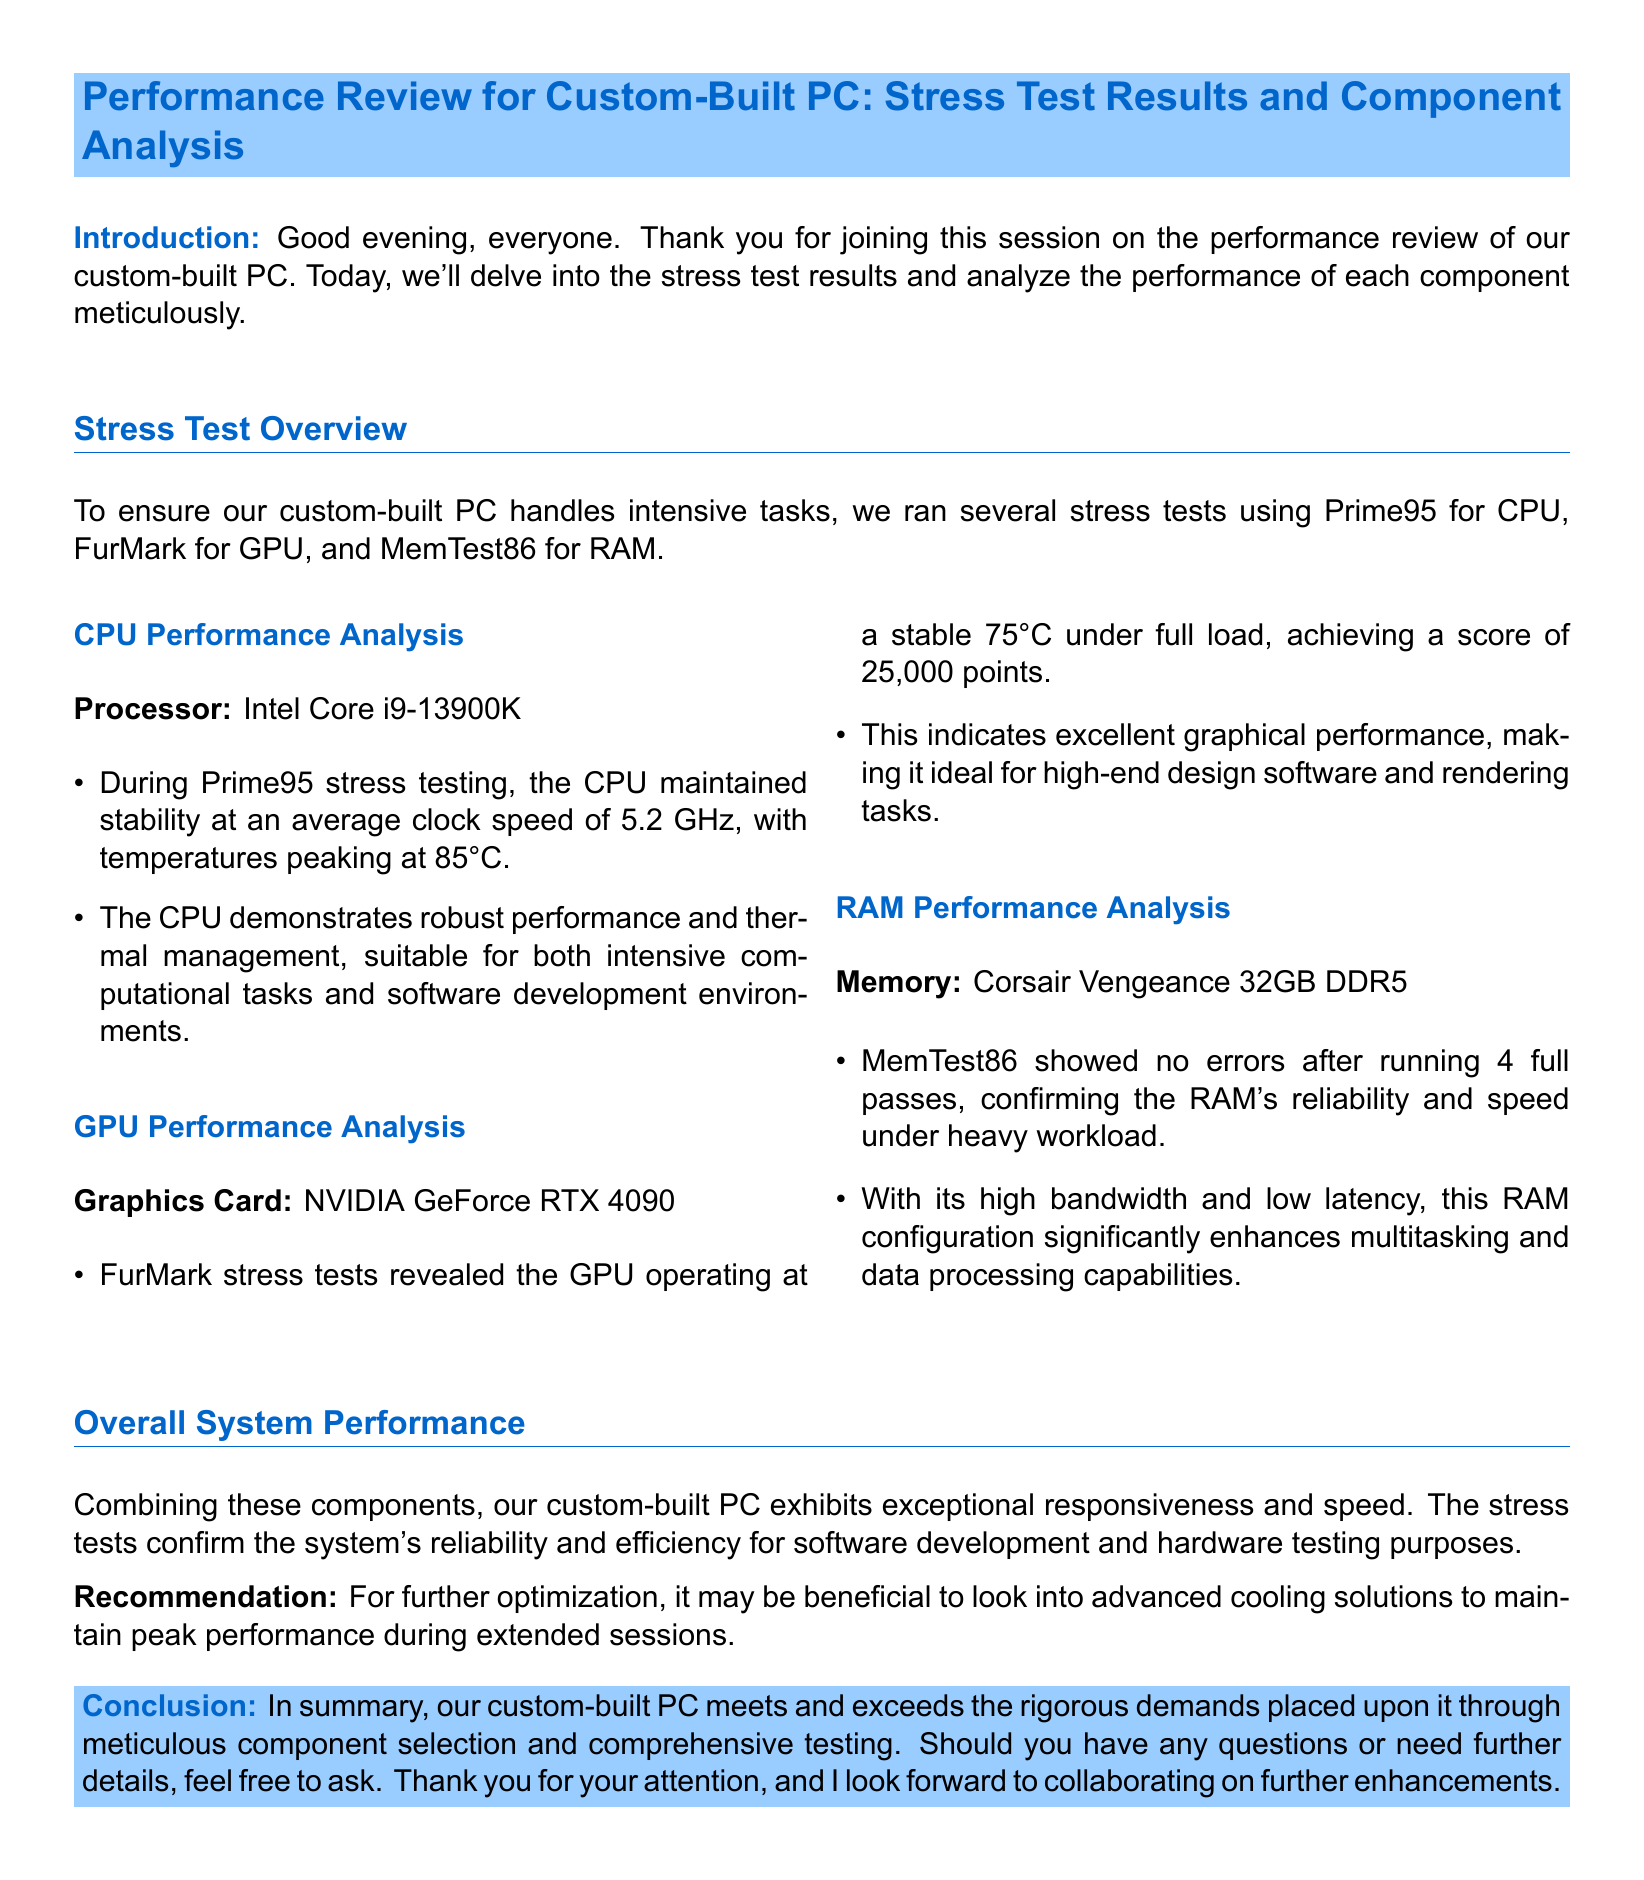What stress testing software was used for the CPU? The document specifies that Prime95 was the software used for CPU stress testing.
Answer: Prime95 What was the peak temperature for the CPU during testing? According to the document, the CPU peaked at a temperature of 85°C during stress testing.
Answer: 85°C What is the average clock speed of the Intel Core i9-13900K CPU? The document states that the CPU maintained an average clock speed of 5.2 GHz during testing.
Answer: 5.2 GHz How many full passes did MemTest86 run? The document mentions that MemTest86 showed no errors after running 4 full passes.
Answer: 4 What was the score achieved by the NVIDIA GeForce RTX 4090 during the stress test? The document indicates that the GPU achieved a score of 25,000 points in the FurMark stress tests.
Answer: 25,000 points What does the RAM configuration enhance? The document states that the high bandwidth and low latency of the RAM significantly enhance multitasking and data processing capabilities.
Answer: Multitasking and data processing capabilities What is recommended for further optimization of the system? The document recommends looking into advanced cooling solutions for maintaining peak performance during extended sessions.
Answer: Advanced cooling solutions Which graphics card was analyzed in this performance review? The document specifies that the graphics card analyzed was the NVIDIA GeForce RTX 4090.
Answer: NVIDIA GeForce RTX 4090 What type of RAM is used in the custom-built PC? The document mentions that the RAM used is Corsair Vengeance 32GB DDR5.
Answer: Corsair Vengeance 32GB DDR5 